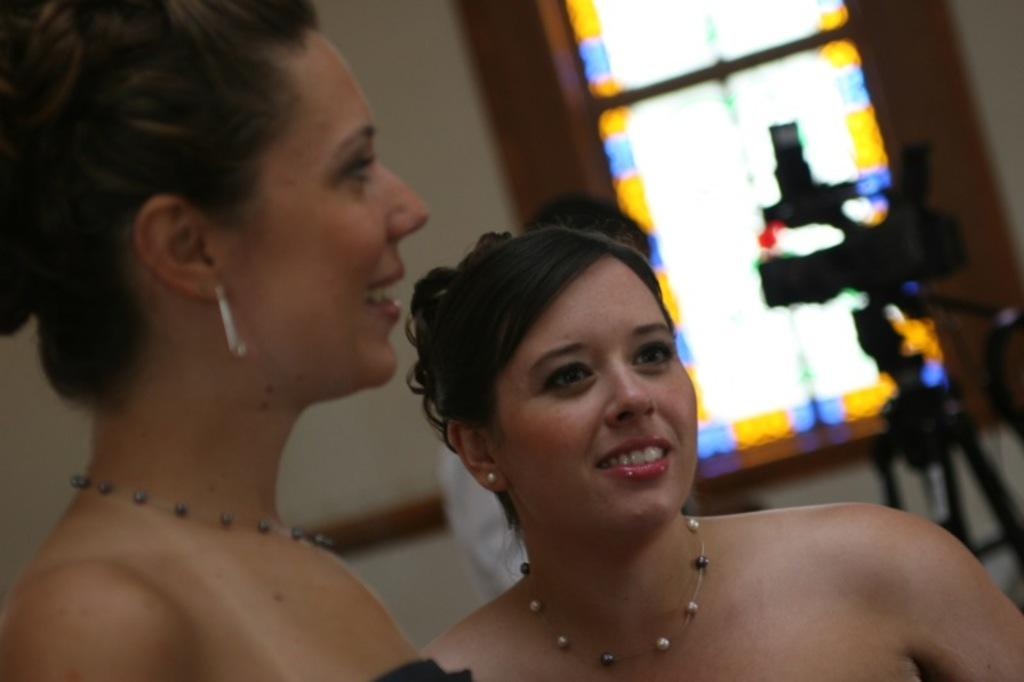How many people are in the image? There are two persons in the image. What object related to photography can be seen in the image? There is a camera on a stand in the image. Can you describe any architectural features in the image? There is a window in the image. What type of seed is being planted by the persons in the image? There is no seed or planting activity depicted in the image; it features two persons and a camera on a stand. What type of clouds can be seen through the window in the image? There is no mention of clouds or a window view in the provided facts, so it cannot be determined from the image. 